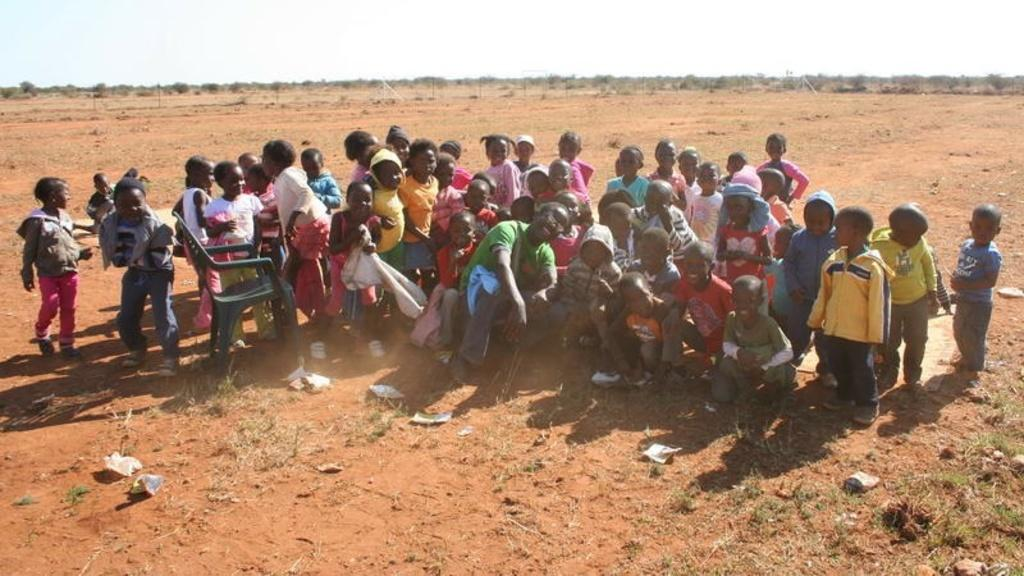What is the main subject of the image? The main subject of the image is a group of children. Can you describe the other people in the image? There is a person in the image. What object is present in the image that might be used for sitting? There is a chair in the image. What type of natural environment can be seen in the image? There are trees in the image. What is visible in the background of the image? The sky is visible in the background of the image. What type of veil can be seen on the chair in the image? There is no veil present on the chair in the image. What color is the yarn that the cub is playing with in the image? There is no cub or yarn present in the image. 